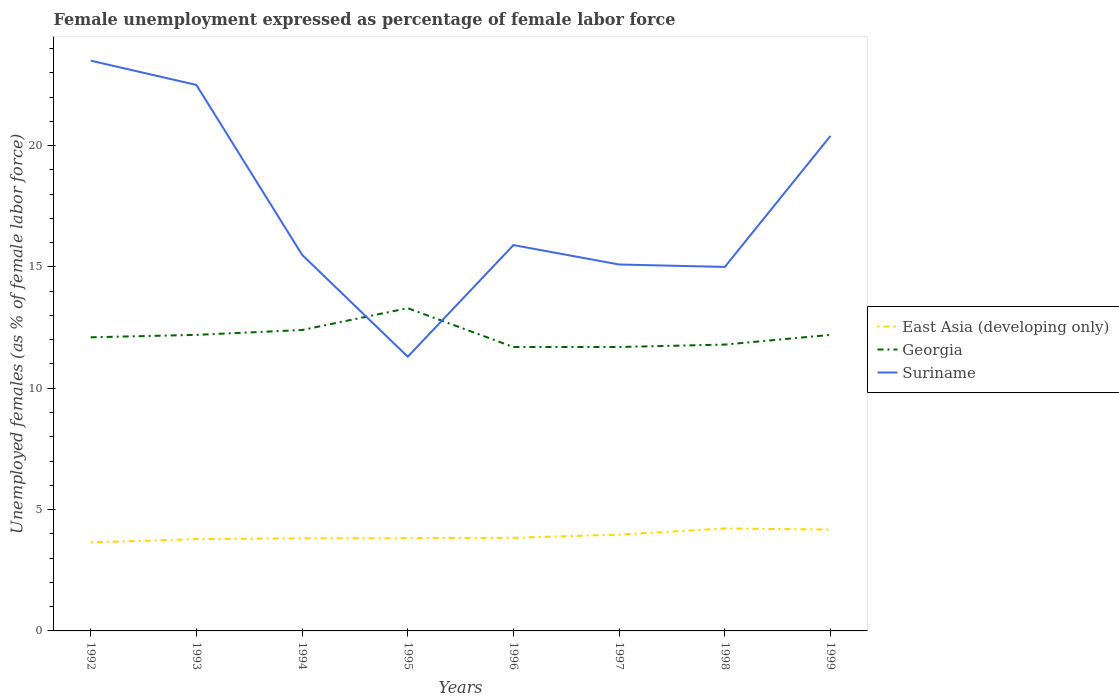Does the line corresponding to Georgia intersect with the line corresponding to East Asia (developing only)?
Offer a very short reply. No. Is the number of lines equal to the number of legend labels?
Make the answer very short. Yes. Across all years, what is the maximum unemployment in females in in East Asia (developing only)?
Offer a very short reply. 3.65. In which year was the unemployment in females in in Georgia maximum?
Offer a very short reply. 1996. What is the total unemployment in females in in East Asia (developing only) in the graph?
Ensure brevity in your answer.  -0.18. What is the difference between the highest and the second highest unemployment in females in in Georgia?
Your answer should be compact. 1.6. What is the difference between the highest and the lowest unemployment in females in in Suriname?
Your answer should be very brief. 3. Is the unemployment in females in in East Asia (developing only) strictly greater than the unemployment in females in in Georgia over the years?
Your answer should be very brief. Yes. How many years are there in the graph?
Your answer should be compact. 8. Does the graph contain any zero values?
Your answer should be very brief. No. Does the graph contain grids?
Provide a succinct answer. No. Where does the legend appear in the graph?
Make the answer very short. Center right. What is the title of the graph?
Ensure brevity in your answer.  Female unemployment expressed as percentage of female labor force. What is the label or title of the X-axis?
Offer a terse response. Years. What is the label or title of the Y-axis?
Make the answer very short. Unemployed females (as % of female labor force). What is the Unemployed females (as % of female labor force) of East Asia (developing only) in 1992?
Your answer should be compact. 3.65. What is the Unemployed females (as % of female labor force) of Georgia in 1992?
Your response must be concise. 12.1. What is the Unemployed females (as % of female labor force) of Suriname in 1992?
Your answer should be very brief. 23.5. What is the Unemployed females (as % of female labor force) in East Asia (developing only) in 1993?
Your answer should be compact. 3.78. What is the Unemployed females (as % of female labor force) in Georgia in 1993?
Ensure brevity in your answer.  12.2. What is the Unemployed females (as % of female labor force) in East Asia (developing only) in 1994?
Your response must be concise. 3.82. What is the Unemployed females (as % of female labor force) in Georgia in 1994?
Your response must be concise. 12.4. What is the Unemployed females (as % of female labor force) in Suriname in 1994?
Offer a terse response. 15.5. What is the Unemployed females (as % of female labor force) in East Asia (developing only) in 1995?
Your answer should be compact. 3.82. What is the Unemployed females (as % of female labor force) in Georgia in 1995?
Give a very brief answer. 13.3. What is the Unemployed females (as % of female labor force) in Suriname in 1995?
Give a very brief answer. 11.3. What is the Unemployed females (as % of female labor force) in East Asia (developing only) in 1996?
Give a very brief answer. 3.84. What is the Unemployed females (as % of female labor force) of Georgia in 1996?
Provide a succinct answer. 11.7. What is the Unemployed females (as % of female labor force) in Suriname in 1996?
Your answer should be compact. 15.9. What is the Unemployed females (as % of female labor force) in East Asia (developing only) in 1997?
Offer a terse response. 3.97. What is the Unemployed females (as % of female labor force) in Georgia in 1997?
Ensure brevity in your answer.  11.7. What is the Unemployed females (as % of female labor force) in Suriname in 1997?
Keep it short and to the point. 15.1. What is the Unemployed females (as % of female labor force) in East Asia (developing only) in 1998?
Offer a very short reply. 4.22. What is the Unemployed females (as % of female labor force) of Georgia in 1998?
Your answer should be compact. 11.8. What is the Unemployed females (as % of female labor force) of Suriname in 1998?
Offer a terse response. 15. What is the Unemployed females (as % of female labor force) of East Asia (developing only) in 1999?
Your answer should be compact. 4.18. What is the Unemployed females (as % of female labor force) of Georgia in 1999?
Give a very brief answer. 12.2. What is the Unemployed females (as % of female labor force) of Suriname in 1999?
Provide a short and direct response. 20.4. Across all years, what is the maximum Unemployed females (as % of female labor force) of East Asia (developing only)?
Your answer should be very brief. 4.22. Across all years, what is the maximum Unemployed females (as % of female labor force) of Georgia?
Offer a terse response. 13.3. Across all years, what is the maximum Unemployed females (as % of female labor force) in Suriname?
Your response must be concise. 23.5. Across all years, what is the minimum Unemployed females (as % of female labor force) of East Asia (developing only)?
Offer a terse response. 3.65. Across all years, what is the minimum Unemployed females (as % of female labor force) in Georgia?
Give a very brief answer. 11.7. Across all years, what is the minimum Unemployed females (as % of female labor force) of Suriname?
Keep it short and to the point. 11.3. What is the total Unemployed females (as % of female labor force) of East Asia (developing only) in the graph?
Your answer should be compact. 31.27. What is the total Unemployed females (as % of female labor force) of Georgia in the graph?
Offer a very short reply. 97.4. What is the total Unemployed females (as % of female labor force) in Suriname in the graph?
Your answer should be very brief. 139.2. What is the difference between the Unemployed females (as % of female labor force) of East Asia (developing only) in 1992 and that in 1993?
Make the answer very short. -0.14. What is the difference between the Unemployed females (as % of female labor force) in Suriname in 1992 and that in 1993?
Provide a succinct answer. 1. What is the difference between the Unemployed females (as % of female labor force) in East Asia (developing only) in 1992 and that in 1994?
Provide a succinct answer. -0.17. What is the difference between the Unemployed females (as % of female labor force) in East Asia (developing only) in 1992 and that in 1995?
Your answer should be compact. -0.18. What is the difference between the Unemployed females (as % of female labor force) in East Asia (developing only) in 1992 and that in 1996?
Give a very brief answer. -0.19. What is the difference between the Unemployed females (as % of female labor force) of Georgia in 1992 and that in 1996?
Make the answer very short. 0.4. What is the difference between the Unemployed females (as % of female labor force) in Suriname in 1992 and that in 1996?
Your answer should be compact. 7.6. What is the difference between the Unemployed females (as % of female labor force) of East Asia (developing only) in 1992 and that in 1997?
Make the answer very short. -0.32. What is the difference between the Unemployed females (as % of female labor force) in Suriname in 1992 and that in 1997?
Offer a very short reply. 8.4. What is the difference between the Unemployed females (as % of female labor force) in East Asia (developing only) in 1992 and that in 1998?
Make the answer very short. -0.57. What is the difference between the Unemployed females (as % of female labor force) in East Asia (developing only) in 1992 and that in 1999?
Offer a very short reply. -0.53. What is the difference between the Unemployed females (as % of female labor force) in Suriname in 1992 and that in 1999?
Offer a terse response. 3.1. What is the difference between the Unemployed females (as % of female labor force) of East Asia (developing only) in 1993 and that in 1994?
Ensure brevity in your answer.  -0.03. What is the difference between the Unemployed females (as % of female labor force) in Georgia in 1993 and that in 1994?
Provide a short and direct response. -0.2. What is the difference between the Unemployed females (as % of female labor force) in East Asia (developing only) in 1993 and that in 1995?
Your answer should be compact. -0.04. What is the difference between the Unemployed females (as % of female labor force) of Georgia in 1993 and that in 1995?
Provide a short and direct response. -1.1. What is the difference between the Unemployed females (as % of female labor force) in Suriname in 1993 and that in 1995?
Ensure brevity in your answer.  11.2. What is the difference between the Unemployed females (as % of female labor force) in East Asia (developing only) in 1993 and that in 1996?
Offer a terse response. -0.05. What is the difference between the Unemployed females (as % of female labor force) in East Asia (developing only) in 1993 and that in 1997?
Your answer should be very brief. -0.18. What is the difference between the Unemployed females (as % of female labor force) in East Asia (developing only) in 1993 and that in 1998?
Offer a very short reply. -0.44. What is the difference between the Unemployed females (as % of female labor force) in East Asia (developing only) in 1993 and that in 1999?
Your answer should be very brief. -0.39. What is the difference between the Unemployed females (as % of female labor force) in Georgia in 1993 and that in 1999?
Your response must be concise. 0. What is the difference between the Unemployed females (as % of female labor force) of Suriname in 1993 and that in 1999?
Keep it short and to the point. 2.1. What is the difference between the Unemployed females (as % of female labor force) in East Asia (developing only) in 1994 and that in 1995?
Keep it short and to the point. -0.01. What is the difference between the Unemployed females (as % of female labor force) in Georgia in 1994 and that in 1995?
Provide a succinct answer. -0.9. What is the difference between the Unemployed females (as % of female labor force) in Suriname in 1994 and that in 1995?
Give a very brief answer. 4.2. What is the difference between the Unemployed females (as % of female labor force) of East Asia (developing only) in 1994 and that in 1996?
Offer a terse response. -0.02. What is the difference between the Unemployed females (as % of female labor force) of Georgia in 1994 and that in 1996?
Give a very brief answer. 0.7. What is the difference between the Unemployed females (as % of female labor force) of East Asia (developing only) in 1994 and that in 1997?
Your answer should be very brief. -0.15. What is the difference between the Unemployed females (as % of female labor force) in Georgia in 1994 and that in 1997?
Provide a succinct answer. 0.7. What is the difference between the Unemployed females (as % of female labor force) in East Asia (developing only) in 1994 and that in 1998?
Give a very brief answer. -0.41. What is the difference between the Unemployed females (as % of female labor force) of Suriname in 1994 and that in 1998?
Offer a terse response. 0.5. What is the difference between the Unemployed females (as % of female labor force) in East Asia (developing only) in 1994 and that in 1999?
Make the answer very short. -0.36. What is the difference between the Unemployed females (as % of female labor force) of Georgia in 1994 and that in 1999?
Make the answer very short. 0.2. What is the difference between the Unemployed females (as % of female labor force) in Suriname in 1994 and that in 1999?
Make the answer very short. -4.9. What is the difference between the Unemployed females (as % of female labor force) of East Asia (developing only) in 1995 and that in 1996?
Give a very brief answer. -0.01. What is the difference between the Unemployed females (as % of female labor force) in Georgia in 1995 and that in 1996?
Keep it short and to the point. 1.6. What is the difference between the Unemployed females (as % of female labor force) of East Asia (developing only) in 1995 and that in 1997?
Ensure brevity in your answer.  -0.14. What is the difference between the Unemployed females (as % of female labor force) of East Asia (developing only) in 1995 and that in 1998?
Your answer should be very brief. -0.4. What is the difference between the Unemployed females (as % of female labor force) in Georgia in 1995 and that in 1998?
Offer a very short reply. 1.5. What is the difference between the Unemployed females (as % of female labor force) of Suriname in 1995 and that in 1998?
Give a very brief answer. -3.7. What is the difference between the Unemployed females (as % of female labor force) in East Asia (developing only) in 1995 and that in 1999?
Your answer should be very brief. -0.35. What is the difference between the Unemployed females (as % of female labor force) of East Asia (developing only) in 1996 and that in 1997?
Make the answer very short. -0.13. What is the difference between the Unemployed females (as % of female labor force) of Suriname in 1996 and that in 1997?
Your answer should be very brief. 0.8. What is the difference between the Unemployed females (as % of female labor force) of East Asia (developing only) in 1996 and that in 1998?
Offer a very short reply. -0.38. What is the difference between the Unemployed females (as % of female labor force) in East Asia (developing only) in 1996 and that in 1999?
Your answer should be very brief. -0.34. What is the difference between the Unemployed females (as % of female labor force) of Suriname in 1996 and that in 1999?
Ensure brevity in your answer.  -4.5. What is the difference between the Unemployed females (as % of female labor force) in East Asia (developing only) in 1997 and that in 1998?
Your answer should be compact. -0.25. What is the difference between the Unemployed females (as % of female labor force) of Georgia in 1997 and that in 1998?
Provide a succinct answer. -0.1. What is the difference between the Unemployed females (as % of female labor force) of East Asia (developing only) in 1997 and that in 1999?
Give a very brief answer. -0.21. What is the difference between the Unemployed females (as % of female labor force) in Suriname in 1997 and that in 1999?
Offer a terse response. -5.3. What is the difference between the Unemployed females (as % of female labor force) in East Asia (developing only) in 1998 and that in 1999?
Keep it short and to the point. 0.05. What is the difference between the Unemployed females (as % of female labor force) in Georgia in 1998 and that in 1999?
Offer a very short reply. -0.4. What is the difference between the Unemployed females (as % of female labor force) of East Asia (developing only) in 1992 and the Unemployed females (as % of female labor force) of Georgia in 1993?
Give a very brief answer. -8.55. What is the difference between the Unemployed females (as % of female labor force) in East Asia (developing only) in 1992 and the Unemployed females (as % of female labor force) in Suriname in 1993?
Your answer should be compact. -18.85. What is the difference between the Unemployed females (as % of female labor force) of Georgia in 1992 and the Unemployed females (as % of female labor force) of Suriname in 1993?
Offer a terse response. -10.4. What is the difference between the Unemployed females (as % of female labor force) of East Asia (developing only) in 1992 and the Unemployed females (as % of female labor force) of Georgia in 1994?
Provide a short and direct response. -8.75. What is the difference between the Unemployed females (as % of female labor force) in East Asia (developing only) in 1992 and the Unemployed females (as % of female labor force) in Suriname in 1994?
Provide a short and direct response. -11.85. What is the difference between the Unemployed females (as % of female labor force) in Georgia in 1992 and the Unemployed females (as % of female labor force) in Suriname in 1994?
Keep it short and to the point. -3.4. What is the difference between the Unemployed females (as % of female labor force) in East Asia (developing only) in 1992 and the Unemployed females (as % of female labor force) in Georgia in 1995?
Offer a terse response. -9.65. What is the difference between the Unemployed females (as % of female labor force) of East Asia (developing only) in 1992 and the Unemployed females (as % of female labor force) of Suriname in 1995?
Your answer should be very brief. -7.65. What is the difference between the Unemployed females (as % of female labor force) of East Asia (developing only) in 1992 and the Unemployed females (as % of female labor force) of Georgia in 1996?
Provide a succinct answer. -8.05. What is the difference between the Unemployed females (as % of female labor force) in East Asia (developing only) in 1992 and the Unemployed females (as % of female labor force) in Suriname in 1996?
Give a very brief answer. -12.25. What is the difference between the Unemployed females (as % of female labor force) of Georgia in 1992 and the Unemployed females (as % of female labor force) of Suriname in 1996?
Your answer should be compact. -3.8. What is the difference between the Unemployed females (as % of female labor force) of East Asia (developing only) in 1992 and the Unemployed females (as % of female labor force) of Georgia in 1997?
Your answer should be very brief. -8.05. What is the difference between the Unemployed females (as % of female labor force) in East Asia (developing only) in 1992 and the Unemployed females (as % of female labor force) in Suriname in 1997?
Your response must be concise. -11.45. What is the difference between the Unemployed females (as % of female labor force) of Georgia in 1992 and the Unemployed females (as % of female labor force) of Suriname in 1997?
Provide a short and direct response. -3. What is the difference between the Unemployed females (as % of female labor force) of East Asia (developing only) in 1992 and the Unemployed females (as % of female labor force) of Georgia in 1998?
Provide a short and direct response. -8.15. What is the difference between the Unemployed females (as % of female labor force) of East Asia (developing only) in 1992 and the Unemployed females (as % of female labor force) of Suriname in 1998?
Offer a very short reply. -11.35. What is the difference between the Unemployed females (as % of female labor force) in Georgia in 1992 and the Unemployed females (as % of female labor force) in Suriname in 1998?
Offer a very short reply. -2.9. What is the difference between the Unemployed females (as % of female labor force) in East Asia (developing only) in 1992 and the Unemployed females (as % of female labor force) in Georgia in 1999?
Your answer should be very brief. -8.55. What is the difference between the Unemployed females (as % of female labor force) in East Asia (developing only) in 1992 and the Unemployed females (as % of female labor force) in Suriname in 1999?
Offer a terse response. -16.75. What is the difference between the Unemployed females (as % of female labor force) in Georgia in 1992 and the Unemployed females (as % of female labor force) in Suriname in 1999?
Your response must be concise. -8.3. What is the difference between the Unemployed females (as % of female labor force) of East Asia (developing only) in 1993 and the Unemployed females (as % of female labor force) of Georgia in 1994?
Ensure brevity in your answer.  -8.62. What is the difference between the Unemployed females (as % of female labor force) in East Asia (developing only) in 1993 and the Unemployed females (as % of female labor force) in Suriname in 1994?
Your response must be concise. -11.72. What is the difference between the Unemployed females (as % of female labor force) in East Asia (developing only) in 1993 and the Unemployed females (as % of female labor force) in Georgia in 1995?
Provide a short and direct response. -9.52. What is the difference between the Unemployed females (as % of female labor force) of East Asia (developing only) in 1993 and the Unemployed females (as % of female labor force) of Suriname in 1995?
Make the answer very short. -7.52. What is the difference between the Unemployed females (as % of female labor force) in East Asia (developing only) in 1993 and the Unemployed females (as % of female labor force) in Georgia in 1996?
Provide a succinct answer. -7.92. What is the difference between the Unemployed females (as % of female labor force) of East Asia (developing only) in 1993 and the Unemployed females (as % of female labor force) of Suriname in 1996?
Make the answer very short. -12.12. What is the difference between the Unemployed females (as % of female labor force) in Georgia in 1993 and the Unemployed females (as % of female labor force) in Suriname in 1996?
Your response must be concise. -3.7. What is the difference between the Unemployed females (as % of female labor force) of East Asia (developing only) in 1993 and the Unemployed females (as % of female labor force) of Georgia in 1997?
Your answer should be very brief. -7.92. What is the difference between the Unemployed females (as % of female labor force) of East Asia (developing only) in 1993 and the Unemployed females (as % of female labor force) of Suriname in 1997?
Offer a terse response. -11.32. What is the difference between the Unemployed females (as % of female labor force) in Georgia in 1993 and the Unemployed females (as % of female labor force) in Suriname in 1997?
Ensure brevity in your answer.  -2.9. What is the difference between the Unemployed females (as % of female labor force) in East Asia (developing only) in 1993 and the Unemployed females (as % of female labor force) in Georgia in 1998?
Your answer should be very brief. -8.02. What is the difference between the Unemployed females (as % of female labor force) in East Asia (developing only) in 1993 and the Unemployed females (as % of female labor force) in Suriname in 1998?
Ensure brevity in your answer.  -11.22. What is the difference between the Unemployed females (as % of female labor force) of Georgia in 1993 and the Unemployed females (as % of female labor force) of Suriname in 1998?
Your answer should be compact. -2.8. What is the difference between the Unemployed females (as % of female labor force) of East Asia (developing only) in 1993 and the Unemployed females (as % of female labor force) of Georgia in 1999?
Offer a very short reply. -8.42. What is the difference between the Unemployed females (as % of female labor force) in East Asia (developing only) in 1993 and the Unemployed females (as % of female labor force) in Suriname in 1999?
Offer a terse response. -16.62. What is the difference between the Unemployed females (as % of female labor force) in Georgia in 1993 and the Unemployed females (as % of female labor force) in Suriname in 1999?
Provide a short and direct response. -8.2. What is the difference between the Unemployed females (as % of female labor force) in East Asia (developing only) in 1994 and the Unemployed females (as % of female labor force) in Georgia in 1995?
Offer a terse response. -9.48. What is the difference between the Unemployed females (as % of female labor force) of East Asia (developing only) in 1994 and the Unemployed females (as % of female labor force) of Suriname in 1995?
Give a very brief answer. -7.48. What is the difference between the Unemployed females (as % of female labor force) in East Asia (developing only) in 1994 and the Unemployed females (as % of female labor force) in Georgia in 1996?
Keep it short and to the point. -7.88. What is the difference between the Unemployed females (as % of female labor force) of East Asia (developing only) in 1994 and the Unemployed females (as % of female labor force) of Suriname in 1996?
Keep it short and to the point. -12.08. What is the difference between the Unemployed females (as % of female labor force) of East Asia (developing only) in 1994 and the Unemployed females (as % of female labor force) of Georgia in 1997?
Your answer should be compact. -7.88. What is the difference between the Unemployed females (as % of female labor force) of East Asia (developing only) in 1994 and the Unemployed females (as % of female labor force) of Suriname in 1997?
Offer a very short reply. -11.28. What is the difference between the Unemployed females (as % of female labor force) in Georgia in 1994 and the Unemployed females (as % of female labor force) in Suriname in 1997?
Your response must be concise. -2.7. What is the difference between the Unemployed females (as % of female labor force) in East Asia (developing only) in 1994 and the Unemployed females (as % of female labor force) in Georgia in 1998?
Provide a succinct answer. -7.98. What is the difference between the Unemployed females (as % of female labor force) of East Asia (developing only) in 1994 and the Unemployed females (as % of female labor force) of Suriname in 1998?
Give a very brief answer. -11.18. What is the difference between the Unemployed females (as % of female labor force) of Georgia in 1994 and the Unemployed females (as % of female labor force) of Suriname in 1998?
Provide a succinct answer. -2.6. What is the difference between the Unemployed females (as % of female labor force) in East Asia (developing only) in 1994 and the Unemployed females (as % of female labor force) in Georgia in 1999?
Ensure brevity in your answer.  -8.38. What is the difference between the Unemployed females (as % of female labor force) in East Asia (developing only) in 1994 and the Unemployed females (as % of female labor force) in Suriname in 1999?
Provide a short and direct response. -16.58. What is the difference between the Unemployed females (as % of female labor force) in Georgia in 1994 and the Unemployed females (as % of female labor force) in Suriname in 1999?
Offer a terse response. -8. What is the difference between the Unemployed females (as % of female labor force) of East Asia (developing only) in 1995 and the Unemployed females (as % of female labor force) of Georgia in 1996?
Provide a succinct answer. -7.88. What is the difference between the Unemployed females (as % of female labor force) of East Asia (developing only) in 1995 and the Unemployed females (as % of female labor force) of Suriname in 1996?
Provide a succinct answer. -12.08. What is the difference between the Unemployed females (as % of female labor force) of East Asia (developing only) in 1995 and the Unemployed females (as % of female labor force) of Georgia in 1997?
Offer a terse response. -7.88. What is the difference between the Unemployed females (as % of female labor force) of East Asia (developing only) in 1995 and the Unemployed females (as % of female labor force) of Suriname in 1997?
Provide a short and direct response. -11.28. What is the difference between the Unemployed females (as % of female labor force) in Georgia in 1995 and the Unemployed females (as % of female labor force) in Suriname in 1997?
Offer a very short reply. -1.8. What is the difference between the Unemployed females (as % of female labor force) in East Asia (developing only) in 1995 and the Unemployed females (as % of female labor force) in Georgia in 1998?
Ensure brevity in your answer.  -7.98. What is the difference between the Unemployed females (as % of female labor force) of East Asia (developing only) in 1995 and the Unemployed females (as % of female labor force) of Suriname in 1998?
Make the answer very short. -11.18. What is the difference between the Unemployed females (as % of female labor force) of Georgia in 1995 and the Unemployed females (as % of female labor force) of Suriname in 1998?
Provide a succinct answer. -1.7. What is the difference between the Unemployed females (as % of female labor force) of East Asia (developing only) in 1995 and the Unemployed females (as % of female labor force) of Georgia in 1999?
Your response must be concise. -8.38. What is the difference between the Unemployed females (as % of female labor force) of East Asia (developing only) in 1995 and the Unemployed females (as % of female labor force) of Suriname in 1999?
Offer a terse response. -16.58. What is the difference between the Unemployed females (as % of female labor force) of East Asia (developing only) in 1996 and the Unemployed females (as % of female labor force) of Georgia in 1997?
Provide a succinct answer. -7.86. What is the difference between the Unemployed females (as % of female labor force) of East Asia (developing only) in 1996 and the Unemployed females (as % of female labor force) of Suriname in 1997?
Provide a short and direct response. -11.26. What is the difference between the Unemployed females (as % of female labor force) of Georgia in 1996 and the Unemployed females (as % of female labor force) of Suriname in 1997?
Provide a short and direct response. -3.4. What is the difference between the Unemployed females (as % of female labor force) in East Asia (developing only) in 1996 and the Unemployed females (as % of female labor force) in Georgia in 1998?
Make the answer very short. -7.96. What is the difference between the Unemployed females (as % of female labor force) in East Asia (developing only) in 1996 and the Unemployed females (as % of female labor force) in Suriname in 1998?
Your answer should be compact. -11.16. What is the difference between the Unemployed females (as % of female labor force) of East Asia (developing only) in 1996 and the Unemployed females (as % of female labor force) of Georgia in 1999?
Make the answer very short. -8.36. What is the difference between the Unemployed females (as % of female labor force) of East Asia (developing only) in 1996 and the Unemployed females (as % of female labor force) of Suriname in 1999?
Your response must be concise. -16.56. What is the difference between the Unemployed females (as % of female labor force) of Georgia in 1996 and the Unemployed females (as % of female labor force) of Suriname in 1999?
Your answer should be compact. -8.7. What is the difference between the Unemployed females (as % of female labor force) in East Asia (developing only) in 1997 and the Unemployed females (as % of female labor force) in Georgia in 1998?
Offer a very short reply. -7.83. What is the difference between the Unemployed females (as % of female labor force) in East Asia (developing only) in 1997 and the Unemployed females (as % of female labor force) in Suriname in 1998?
Ensure brevity in your answer.  -11.03. What is the difference between the Unemployed females (as % of female labor force) of East Asia (developing only) in 1997 and the Unemployed females (as % of female labor force) of Georgia in 1999?
Ensure brevity in your answer.  -8.23. What is the difference between the Unemployed females (as % of female labor force) in East Asia (developing only) in 1997 and the Unemployed females (as % of female labor force) in Suriname in 1999?
Offer a very short reply. -16.43. What is the difference between the Unemployed females (as % of female labor force) in East Asia (developing only) in 1998 and the Unemployed females (as % of female labor force) in Georgia in 1999?
Provide a short and direct response. -7.98. What is the difference between the Unemployed females (as % of female labor force) in East Asia (developing only) in 1998 and the Unemployed females (as % of female labor force) in Suriname in 1999?
Your response must be concise. -16.18. What is the difference between the Unemployed females (as % of female labor force) of Georgia in 1998 and the Unemployed females (as % of female labor force) of Suriname in 1999?
Offer a terse response. -8.6. What is the average Unemployed females (as % of female labor force) in East Asia (developing only) per year?
Provide a short and direct response. 3.91. What is the average Unemployed females (as % of female labor force) in Georgia per year?
Give a very brief answer. 12.18. In the year 1992, what is the difference between the Unemployed females (as % of female labor force) of East Asia (developing only) and Unemployed females (as % of female labor force) of Georgia?
Your answer should be very brief. -8.45. In the year 1992, what is the difference between the Unemployed females (as % of female labor force) of East Asia (developing only) and Unemployed females (as % of female labor force) of Suriname?
Provide a succinct answer. -19.85. In the year 1993, what is the difference between the Unemployed females (as % of female labor force) in East Asia (developing only) and Unemployed females (as % of female labor force) in Georgia?
Provide a succinct answer. -8.42. In the year 1993, what is the difference between the Unemployed females (as % of female labor force) in East Asia (developing only) and Unemployed females (as % of female labor force) in Suriname?
Your response must be concise. -18.72. In the year 1994, what is the difference between the Unemployed females (as % of female labor force) of East Asia (developing only) and Unemployed females (as % of female labor force) of Georgia?
Make the answer very short. -8.58. In the year 1994, what is the difference between the Unemployed females (as % of female labor force) of East Asia (developing only) and Unemployed females (as % of female labor force) of Suriname?
Your answer should be very brief. -11.68. In the year 1994, what is the difference between the Unemployed females (as % of female labor force) of Georgia and Unemployed females (as % of female labor force) of Suriname?
Keep it short and to the point. -3.1. In the year 1995, what is the difference between the Unemployed females (as % of female labor force) in East Asia (developing only) and Unemployed females (as % of female labor force) in Georgia?
Make the answer very short. -9.48. In the year 1995, what is the difference between the Unemployed females (as % of female labor force) of East Asia (developing only) and Unemployed females (as % of female labor force) of Suriname?
Ensure brevity in your answer.  -7.48. In the year 1996, what is the difference between the Unemployed females (as % of female labor force) of East Asia (developing only) and Unemployed females (as % of female labor force) of Georgia?
Ensure brevity in your answer.  -7.86. In the year 1996, what is the difference between the Unemployed females (as % of female labor force) of East Asia (developing only) and Unemployed females (as % of female labor force) of Suriname?
Your answer should be very brief. -12.06. In the year 1997, what is the difference between the Unemployed females (as % of female labor force) of East Asia (developing only) and Unemployed females (as % of female labor force) of Georgia?
Provide a short and direct response. -7.73. In the year 1997, what is the difference between the Unemployed females (as % of female labor force) of East Asia (developing only) and Unemployed females (as % of female labor force) of Suriname?
Make the answer very short. -11.13. In the year 1997, what is the difference between the Unemployed females (as % of female labor force) in Georgia and Unemployed females (as % of female labor force) in Suriname?
Your response must be concise. -3.4. In the year 1998, what is the difference between the Unemployed females (as % of female labor force) of East Asia (developing only) and Unemployed females (as % of female labor force) of Georgia?
Your answer should be compact. -7.58. In the year 1998, what is the difference between the Unemployed females (as % of female labor force) of East Asia (developing only) and Unemployed females (as % of female labor force) of Suriname?
Your answer should be compact. -10.78. In the year 1998, what is the difference between the Unemployed females (as % of female labor force) of Georgia and Unemployed females (as % of female labor force) of Suriname?
Your answer should be compact. -3.2. In the year 1999, what is the difference between the Unemployed females (as % of female labor force) in East Asia (developing only) and Unemployed females (as % of female labor force) in Georgia?
Keep it short and to the point. -8.02. In the year 1999, what is the difference between the Unemployed females (as % of female labor force) of East Asia (developing only) and Unemployed females (as % of female labor force) of Suriname?
Offer a very short reply. -16.22. In the year 1999, what is the difference between the Unemployed females (as % of female labor force) in Georgia and Unemployed females (as % of female labor force) in Suriname?
Give a very brief answer. -8.2. What is the ratio of the Unemployed females (as % of female labor force) in East Asia (developing only) in 1992 to that in 1993?
Give a very brief answer. 0.96. What is the ratio of the Unemployed females (as % of female labor force) of Suriname in 1992 to that in 1993?
Ensure brevity in your answer.  1.04. What is the ratio of the Unemployed females (as % of female labor force) in East Asia (developing only) in 1992 to that in 1994?
Offer a very short reply. 0.96. What is the ratio of the Unemployed females (as % of female labor force) in Georgia in 1992 to that in 1994?
Keep it short and to the point. 0.98. What is the ratio of the Unemployed females (as % of female labor force) in Suriname in 1992 to that in 1994?
Keep it short and to the point. 1.52. What is the ratio of the Unemployed females (as % of female labor force) in East Asia (developing only) in 1992 to that in 1995?
Your answer should be very brief. 0.95. What is the ratio of the Unemployed females (as % of female labor force) in Georgia in 1992 to that in 1995?
Ensure brevity in your answer.  0.91. What is the ratio of the Unemployed females (as % of female labor force) in Suriname in 1992 to that in 1995?
Your answer should be compact. 2.08. What is the ratio of the Unemployed females (as % of female labor force) of East Asia (developing only) in 1992 to that in 1996?
Provide a succinct answer. 0.95. What is the ratio of the Unemployed females (as % of female labor force) of Georgia in 1992 to that in 1996?
Keep it short and to the point. 1.03. What is the ratio of the Unemployed females (as % of female labor force) in Suriname in 1992 to that in 1996?
Give a very brief answer. 1.48. What is the ratio of the Unemployed females (as % of female labor force) in East Asia (developing only) in 1992 to that in 1997?
Keep it short and to the point. 0.92. What is the ratio of the Unemployed females (as % of female labor force) in Georgia in 1992 to that in 1997?
Your response must be concise. 1.03. What is the ratio of the Unemployed females (as % of female labor force) of Suriname in 1992 to that in 1997?
Ensure brevity in your answer.  1.56. What is the ratio of the Unemployed females (as % of female labor force) in East Asia (developing only) in 1992 to that in 1998?
Offer a very short reply. 0.86. What is the ratio of the Unemployed females (as % of female labor force) in Georgia in 1992 to that in 1998?
Give a very brief answer. 1.03. What is the ratio of the Unemployed females (as % of female labor force) of Suriname in 1992 to that in 1998?
Your answer should be compact. 1.57. What is the ratio of the Unemployed females (as % of female labor force) of East Asia (developing only) in 1992 to that in 1999?
Offer a terse response. 0.87. What is the ratio of the Unemployed females (as % of female labor force) of Suriname in 1992 to that in 1999?
Keep it short and to the point. 1.15. What is the ratio of the Unemployed females (as % of female labor force) in East Asia (developing only) in 1993 to that in 1994?
Give a very brief answer. 0.99. What is the ratio of the Unemployed females (as % of female labor force) in Georgia in 1993 to that in 1994?
Your answer should be compact. 0.98. What is the ratio of the Unemployed females (as % of female labor force) in Suriname in 1993 to that in 1994?
Your answer should be compact. 1.45. What is the ratio of the Unemployed females (as % of female labor force) of East Asia (developing only) in 1993 to that in 1995?
Ensure brevity in your answer.  0.99. What is the ratio of the Unemployed females (as % of female labor force) of Georgia in 1993 to that in 1995?
Offer a terse response. 0.92. What is the ratio of the Unemployed females (as % of female labor force) of Suriname in 1993 to that in 1995?
Ensure brevity in your answer.  1.99. What is the ratio of the Unemployed females (as % of female labor force) in East Asia (developing only) in 1993 to that in 1996?
Offer a terse response. 0.99. What is the ratio of the Unemployed females (as % of female labor force) of Georgia in 1993 to that in 1996?
Your response must be concise. 1.04. What is the ratio of the Unemployed females (as % of female labor force) of Suriname in 1993 to that in 1996?
Provide a short and direct response. 1.42. What is the ratio of the Unemployed females (as % of female labor force) in East Asia (developing only) in 1993 to that in 1997?
Make the answer very short. 0.95. What is the ratio of the Unemployed females (as % of female labor force) in Georgia in 1993 to that in 1997?
Keep it short and to the point. 1.04. What is the ratio of the Unemployed females (as % of female labor force) of Suriname in 1993 to that in 1997?
Offer a very short reply. 1.49. What is the ratio of the Unemployed females (as % of female labor force) of East Asia (developing only) in 1993 to that in 1998?
Ensure brevity in your answer.  0.9. What is the ratio of the Unemployed females (as % of female labor force) of Georgia in 1993 to that in 1998?
Your answer should be compact. 1.03. What is the ratio of the Unemployed females (as % of female labor force) of Suriname in 1993 to that in 1998?
Give a very brief answer. 1.5. What is the ratio of the Unemployed females (as % of female labor force) of East Asia (developing only) in 1993 to that in 1999?
Make the answer very short. 0.91. What is the ratio of the Unemployed females (as % of female labor force) of Georgia in 1993 to that in 1999?
Your response must be concise. 1. What is the ratio of the Unemployed females (as % of female labor force) in Suriname in 1993 to that in 1999?
Provide a succinct answer. 1.1. What is the ratio of the Unemployed females (as % of female labor force) of East Asia (developing only) in 1994 to that in 1995?
Offer a terse response. 1. What is the ratio of the Unemployed females (as % of female labor force) of Georgia in 1994 to that in 1995?
Offer a very short reply. 0.93. What is the ratio of the Unemployed females (as % of female labor force) of Suriname in 1994 to that in 1995?
Offer a very short reply. 1.37. What is the ratio of the Unemployed females (as % of female labor force) of Georgia in 1994 to that in 1996?
Your answer should be compact. 1.06. What is the ratio of the Unemployed females (as % of female labor force) of Suriname in 1994 to that in 1996?
Give a very brief answer. 0.97. What is the ratio of the Unemployed females (as % of female labor force) in East Asia (developing only) in 1994 to that in 1997?
Provide a short and direct response. 0.96. What is the ratio of the Unemployed females (as % of female labor force) of Georgia in 1994 to that in 1997?
Your answer should be very brief. 1.06. What is the ratio of the Unemployed females (as % of female labor force) in Suriname in 1994 to that in 1997?
Make the answer very short. 1.03. What is the ratio of the Unemployed females (as % of female labor force) of East Asia (developing only) in 1994 to that in 1998?
Keep it short and to the point. 0.9. What is the ratio of the Unemployed females (as % of female labor force) in Georgia in 1994 to that in 1998?
Ensure brevity in your answer.  1.05. What is the ratio of the Unemployed females (as % of female labor force) of Suriname in 1994 to that in 1998?
Offer a terse response. 1.03. What is the ratio of the Unemployed females (as % of female labor force) in East Asia (developing only) in 1994 to that in 1999?
Ensure brevity in your answer.  0.91. What is the ratio of the Unemployed females (as % of female labor force) in Georgia in 1994 to that in 1999?
Your response must be concise. 1.02. What is the ratio of the Unemployed females (as % of female labor force) in Suriname in 1994 to that in 1999?
Give a very brief answer. 0.76. What is the ratio of the Unemployed females (as % of female labor force) in Georgia in 1995 to that in 1996?
Your answer should be very brief. 1.14. What is the ratio of the Unemployed females (as % of female labor force) of Suriname in 1995 to that in 1996?
Your response must be concise. 0.71. What is the ratio of the Unemployed females (as % of female labor force) of East Asia (developing only) in 1995 to that in 1997?
Make the answer very short. 0.96. What is the ratio of the Unemployed females (as % of female labor force) of Georgia in 1995 to that in 1997?
Your answer should be very brief. 1.14. What is the ratio of the Unemployed females (as % of female labor force) in Suriname in 1995 to that in 1997?
Your response must be concise. 0.75. What is the ratio of the Unemployed females (as % of female labor force) in East Asia (developing only) in 1995 to that in 1998?
Provide a succinct answer. 0.91. What is the ratio of the Unemployed females (as % of female labor force) in Georgia in 1995 to that in 1998?
Ensure brevity in your answer.  1.13. What is the ratio of the Unemployed females (as % of female labor force) in Suriname in 1995 to that in 1998?
Offer a very short reply. 0.75. What is the ratio of the Unemployed females (as % of female labor force) of East Asia (developing only) in 1995 to that in 1999?
Offer a very short reply. 0.92. What is the ratio of the Unemployed females (as % of female labor force) of Georgia in 1995 to that in 1999?
Keep it short and to the point. 1.09. What is the ratio of the Unemployed females (as % of female labor force) in Suriname in 1995 to that in 1999?
Provide a short and direct response. 0.55. What is the ratio of the Unemployed females (as % of female labor force) of East Asia (developing only) in 1996 to that in 1997?
Offer a terse response. 0.97. What is the ratio of the Unemployed females (as % of female labor force) of Georgia in 1996 to that in 1997?
Give a very brief answer. 1. What is the ratio of the Unemployed females (as % of female labor force) of Suriname in 1996 to that in 1997?
Provide a succinct answer. 1.05. What is the ratio of the Unemployed females (as % of female labor force) of East Asia (developing only) in 1996 to that in 1998?
Provide a short and direct response. 0.91. What is the ratio of the Unemployed females (as % of female labor force) of Suriname in 1996 to that in 1998?
Offer a terse response. 1.06. What is the ratio of the Unemployed females (as % of female labor force) of East Asia (developing only) in 1996 to that in 1999?
Give a very brief answer. 0.92. What is the ratio of the Unemployed females (as % of female labor force) of Suriname in 1996 to that in 1999?
Your response must be concise. 0.78. What is the ratio of the Unemployed females (as % of female labor force) of East Asia (developing only) in 1997 to that in 1998?
Offer a terse response. 0.94. What is the ratio of the Unemployed females (as % of female labor force) in East Asia (developing only) in 1997 to that in 1999?
Offer a terse response. 0.95. What is the ratio of the Unemployed females (as % of female labor force) in Suriname in 1997 to that in 1999?
Ensure brevity in your answer.  0.74. What is the ratio of the Unemployed females (as % of female labor force) of Georgia in 1998 to that in 1999?
Make the answer very short. 0.97. What is the ratio of the Unemployed females (as % of female labor force) in Suriname in 1998 to that in 1999?
Keep it short and to the point. 0.74. What is the difference between the highest and the second highest Unemployed females (as % of female labor force) in East Asia (developing only)?
Provide a short and direct response. 0.05. What is the difference between the highest and the second highest Unemployed females (as % of female labor force) of Georgia?
Provide a short and direct response. 0.9. What is the difference between the highest and the lowest Unemployed females (as % of female labor force) of East Asia (developing only)?
Ensure brevity in your answer.  0.57. What is the difference between the highest and the lowest Unemployed females (as % of female labor force) of Georgia?
Your answer should be very brief. 1.6. What is the difference between the highest and the lowest Unemployed females (as % of female labor force) of Suriname?
Ensure brevity in your answer.  12.2. 